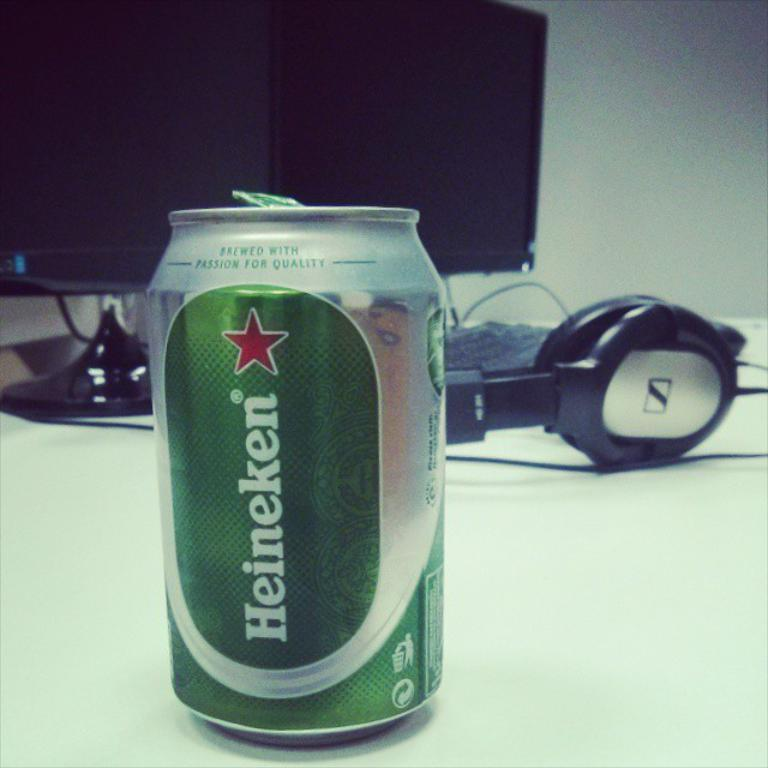<image>
Describe the image concisely. Green and silver Heineken can next to some headphones. 